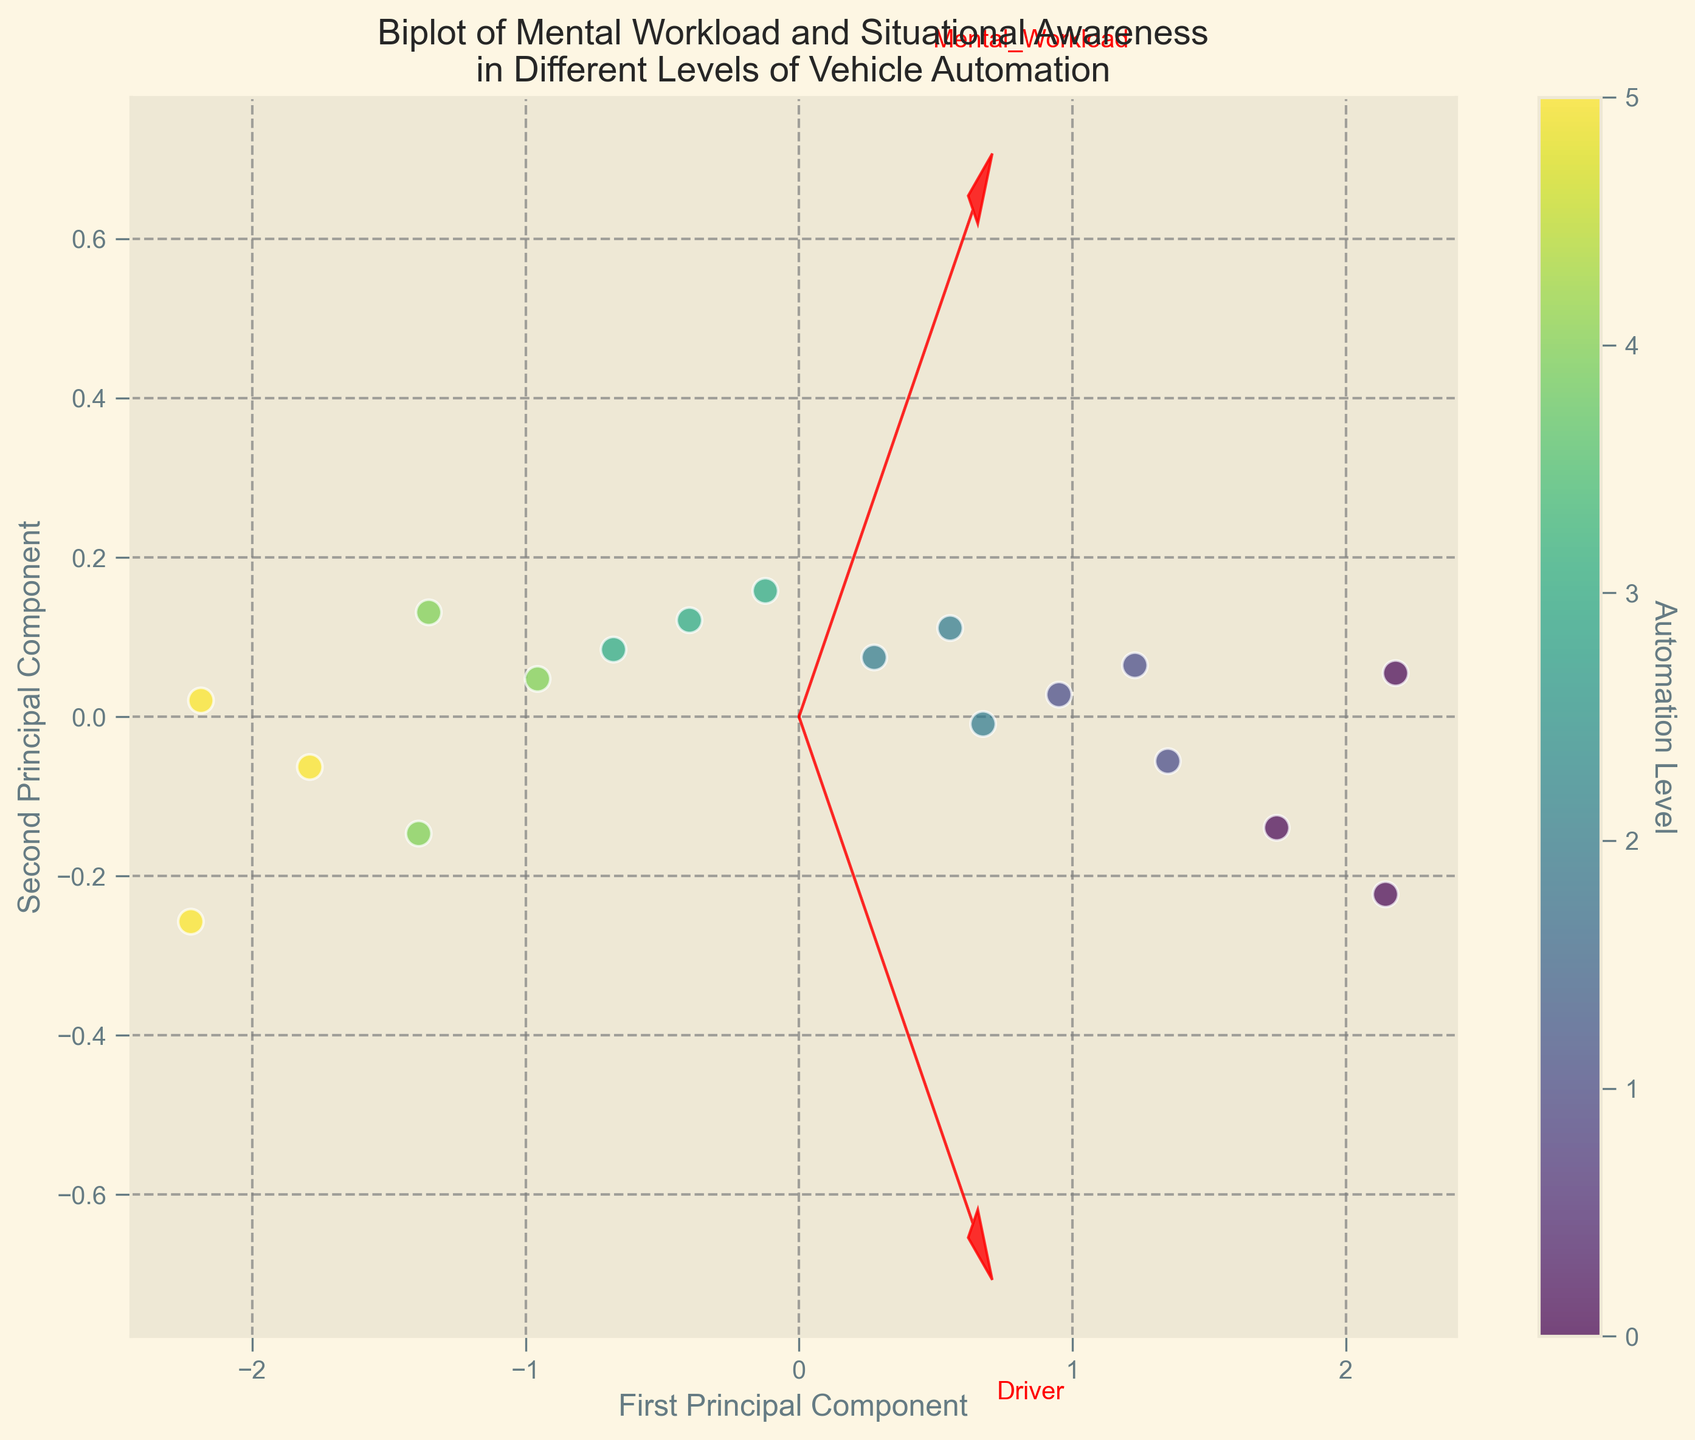What are the axes labels of the plot? The x-axis is labeled 'First Principal Component' and the y-axis is labeled 'Second Principal Component', as visible in the lower part of the plot.
Answer: First Principal Component, Second Principal Component How many different levels of vehicle automation are represented in the colorbar? The colorbar shows distinct shades representing different automation levels ranging from 0 to 5, indicating six different levels.
Answer: 6 Which driver has the highest mental workload and situational awareness combined? From the plot, John (at automation level 0) shows the highest values on both axes (first principal component seems to correspond to a high mental workload and second to situational awareness).
Answer: John How do the mental workload and situational awareness change with increasing automation levels? By observing the data points in the plot, as the automation level increases, both mental workload and situational awareness generally decrease, as seen by the gradient along the principal components.
Answer: Both decrease What do the red arrows represent on the plot? The red arrows represent the directions and contributions of the original features (mental workload and situational awareness) in the transformed PCA space, pointing in the direction of increasing values for these features.
Answer: Directions of the original features Which feature has a stronger influence on the first principal component? From the plot, the arrow representing mental workload has a stronger projection on the first principal component compared to situational awareness, indicating a higher influence.
Answer: Mental workload Is there a driver with a low mental workload but high situational awareness? According to the plot, no specific data points lie far to the right (low mental workload) and high on the second principal component (high situational awareness), indicating that these two features tend to move together in this dataset.
Answer: No Compare the situational awareness of drivers at automation level 0 and 5. Observing the plot, drivers at automation level 0 (represented by darker colors) exhibit higher situational awareness whereas drivers at automation level 5 (represented by lighter colors) have lower situational awareness.
Answer: Level 0 > Level 5 What is the relationship between the two principal components? The plot shows that the first and second principal components are orthogonal, indicating that they are uncorrelated.Each principal components corresponds to a distinct combination of the features (mental workload and situational awareness).
Answer: Uncorrelated 